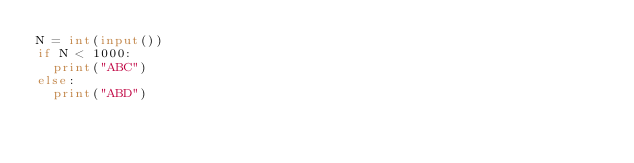<code> <loc_0><loc_0><loc_500><loc_500><_Python_>N = int(input())
if N < 1000:
  print("ABC")
else:
  print("ABD")</code> 